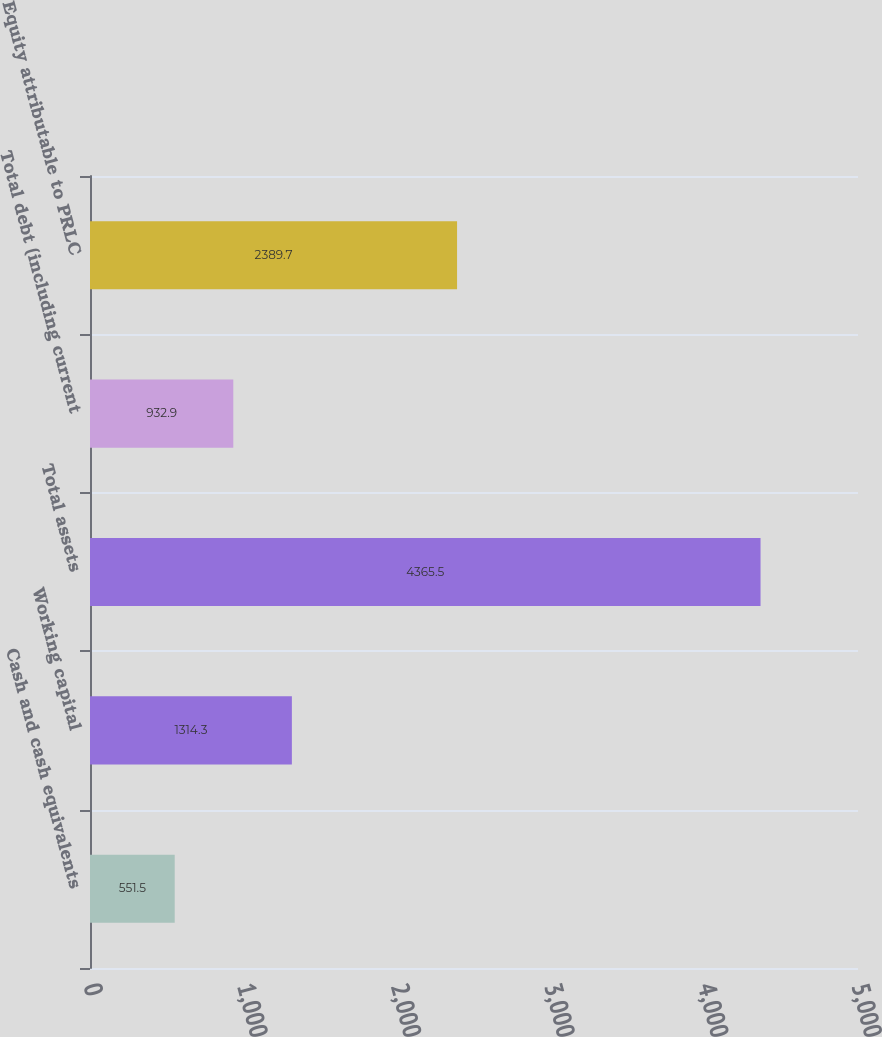Convert chart. <chart><loc_0><loc_0><loc_500><loc_500><bar_chart><fcel>Cash and cash equivalents<fcel>Working capital<fcel>Total assets<fcel>Total debt (including current<fcel>Equity attributable to PRLC<nl><fcel>551.5<fcel>1314.3<fcel>4365.5<fcel>932.9<fcel>2389.7<nl></chart> 